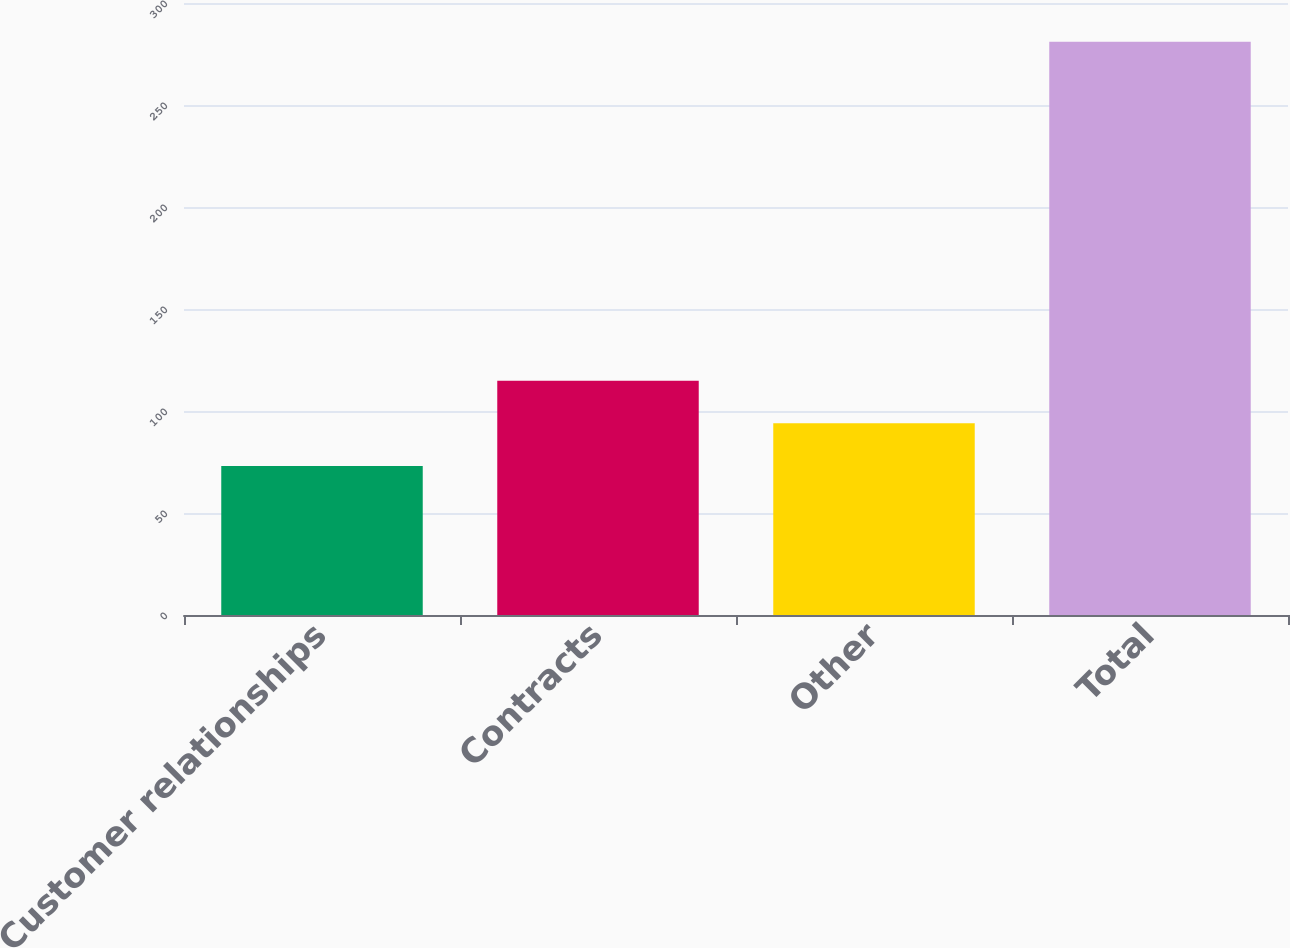<chart> <loc_0><loc_0><loc_500><loc_500><bar_chart><fcel>Customer relationships<fcel>Contracts<fcel>Other<fcel>Total<nl><fcel>73<fcel>114.8<fcel>94<fcel>281<nl></chart> 